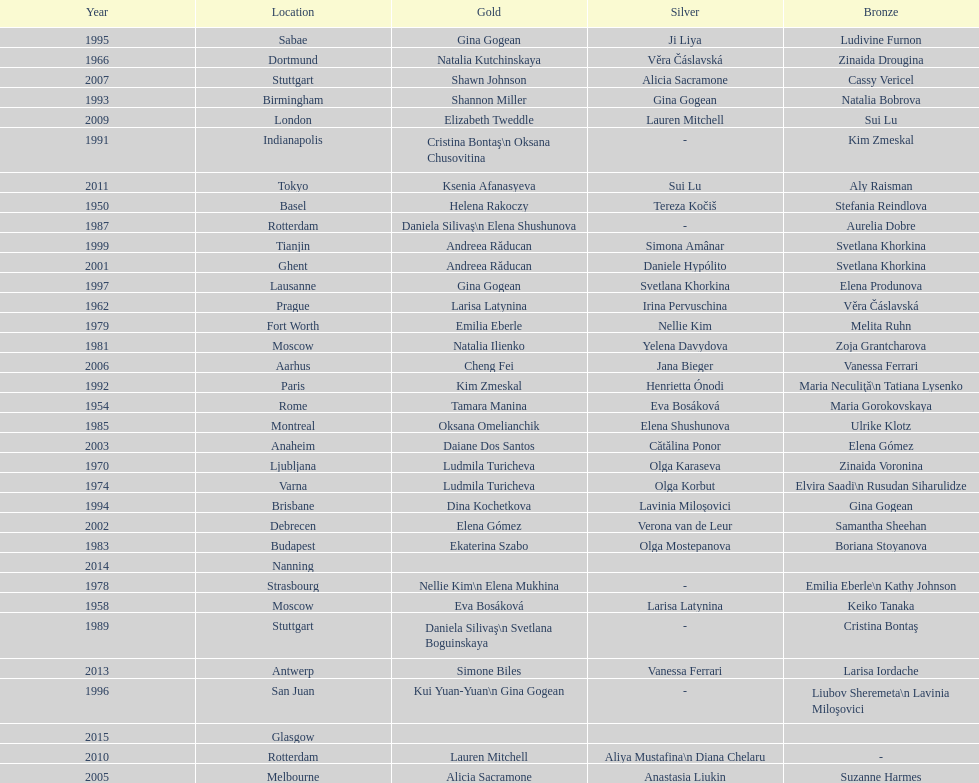How many times was the world artistic gymnastics championships held in the united states? 3. I'm looking to parse the entire table for insights. Could you assist me with that? {'header': ['Year', 'Location', 'Gold', 'Silver', 'Bronze'], 'rows': [['1995', 'Sabae', 'Gina Gogean', 'Ji Liya', 'Ludivine Furnon'], ['1966', 'Dortmund', 'Natalia Kutchinskaya', 'Věra Čáslavská', 'Zinaida Drougina'], ['2007', 'Stuttgart', 'Shawn Johnson', 'Alicia Sacramone', 'Cassy Vericel'], ['1993', 'Birmingham', 'Shannon Miller', 'Gina Gogean', 'Natalia Bobrova'], ['2009', 'London', 'Elizabeth Tweddle', 'Lauren Mitchell', 'Sui Lu'], ['1991', 'Indianapolis', 'Cristina Bontaş\\n Oksana Chusovitina', '-', 'Kim Zmeskal'], ['2011', 'Tokyo', 'Ksenia Afanasyeva', 'Sui Lu', 'Aly Raisman'], ['1950', 'Basel', 'Helena Rakoczy', 'Tereza Kočiš', 'Stefania Reindlova'], ['1987', 'Rotterdam', 'Daniela Silivaş\\n Elena Shushunova', '-', 'Aurelia Dobre'], ['1999', 'Tianjin', 'Andreea Răducan', 'Simona Amânar', 'Svetlana Khorkina'], ['2001', 'Ghent', 'Andreea Răducan', 'Daniele Hypólito', 'Svetlana Khorkina'], ['1997', 'Lausanne', 'Gina Gogean', 'Svetlana Khorkina', 'Elena Produnova'], ['1962', 'Prague', 'Larisa Latynina', 'Irina Pervuschina', 'Věra Čáslavská'], ['1979', 'Fort Worth', 'Emilia Eberle', 'Nellie Kim', 'Melita Ruhn'], ['1981', 'Moscow', 'Natalia Ilienko', 'Yelena Davydova', 'Zoja Grantcharova'], ['2006', 'Aarhus', 'Cheng Fei', 'Jana Bieger', 'Vanessa Ferrari'], ['1992', 'Paris', 'Kim Zmeskal', 'Henrietta Ónodi', 'Maria Neculiţă\\n Tatiana Lysenko'], ['1954', 'Rome', 'Tamara Manina', 'Eva Bosáková', 'Maria Gorokovskaya'], ['1985', 'Montreal', 'Oksana Omelianchik', 'Elena Shushunova', 'Ulrike Klotz'], ['2003', 'Anaheim', 'Daiane Dos Santos', 'Cătălina Ponor', 'Elena Gómez'], ['1970', 'Ljubljana', 'Ludmila Turicheva', 'Olga Karaseva', 'Zinaida Voronina'], ['1974', 'Varna', 'Ludmila Turicheva', 'Olga Korbut', 'Elvira Saadi\\n Rusudan Siharulidze'], ['1994', 'Brisbane', 'Dina Kochetkova', 'Lavinia Miloşovici', 'Gina Gogean'], ['2002', 'Debrecen', 'Elena Gómez', 'Verona van de Leur', 'Samantha Sheehan'], ['1983', 'Budapest', 'Ekaterina Szabo', 'Olga Mostepanova', 'Boriana Stoyanova'], ['2014', 'Nanning', '', '', ''], ['1978', 'Strasbourg', 'Nellie Kim\\n Elena Mukhina', '-', 'Emilia Eberle\\n Kathy Johnson'], ['1958', 'Moscow', 'Eva Bosáková', 'Larisa Latynina', 'Keiko Tanaka'], ['1989', 'Stuttgart', 'Daniela Silivaş\\n Svetlana Boguinskaya', '-', 'Cristina Bontaş'], ['2013', 'Antwerp', 'Simone Biles', 'Vanessa Ferrari', 'Larisa Iordache'], ['1996', 'San Juan', 'Kui Yuan-Yuan\\n Gina Gogean', '-', 'Liubov Sheremeta\\n Lavinia Miloşovici'], ['2015', 'Glasgow', '', '', ''], ['2010', 'Rotterdam', 'Lauren Mitchell', 'Aliya Mustafina\\n Diana Chelaru', '-'], ['2005', 'Melbourne', 'Alicia Sacramone', 'Anastasia Liukin', 'Suzanne Harmes']]} 